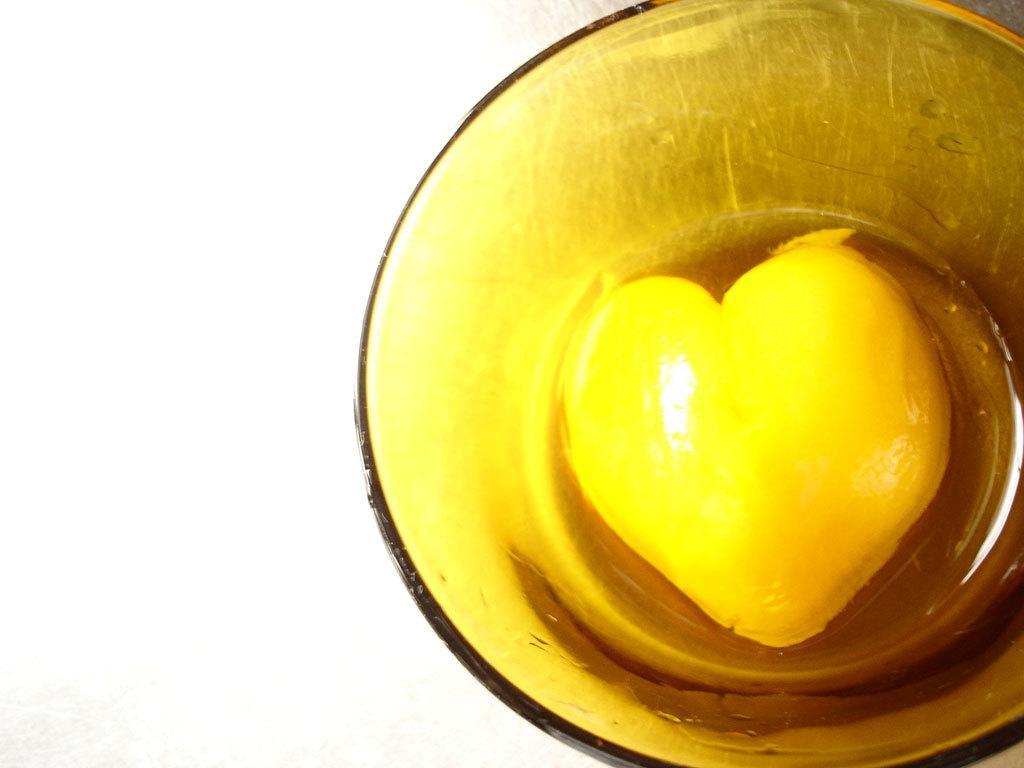How would you summarize this image in a sentence or two? In this image we can see a bowl containing food placed on the surface. 